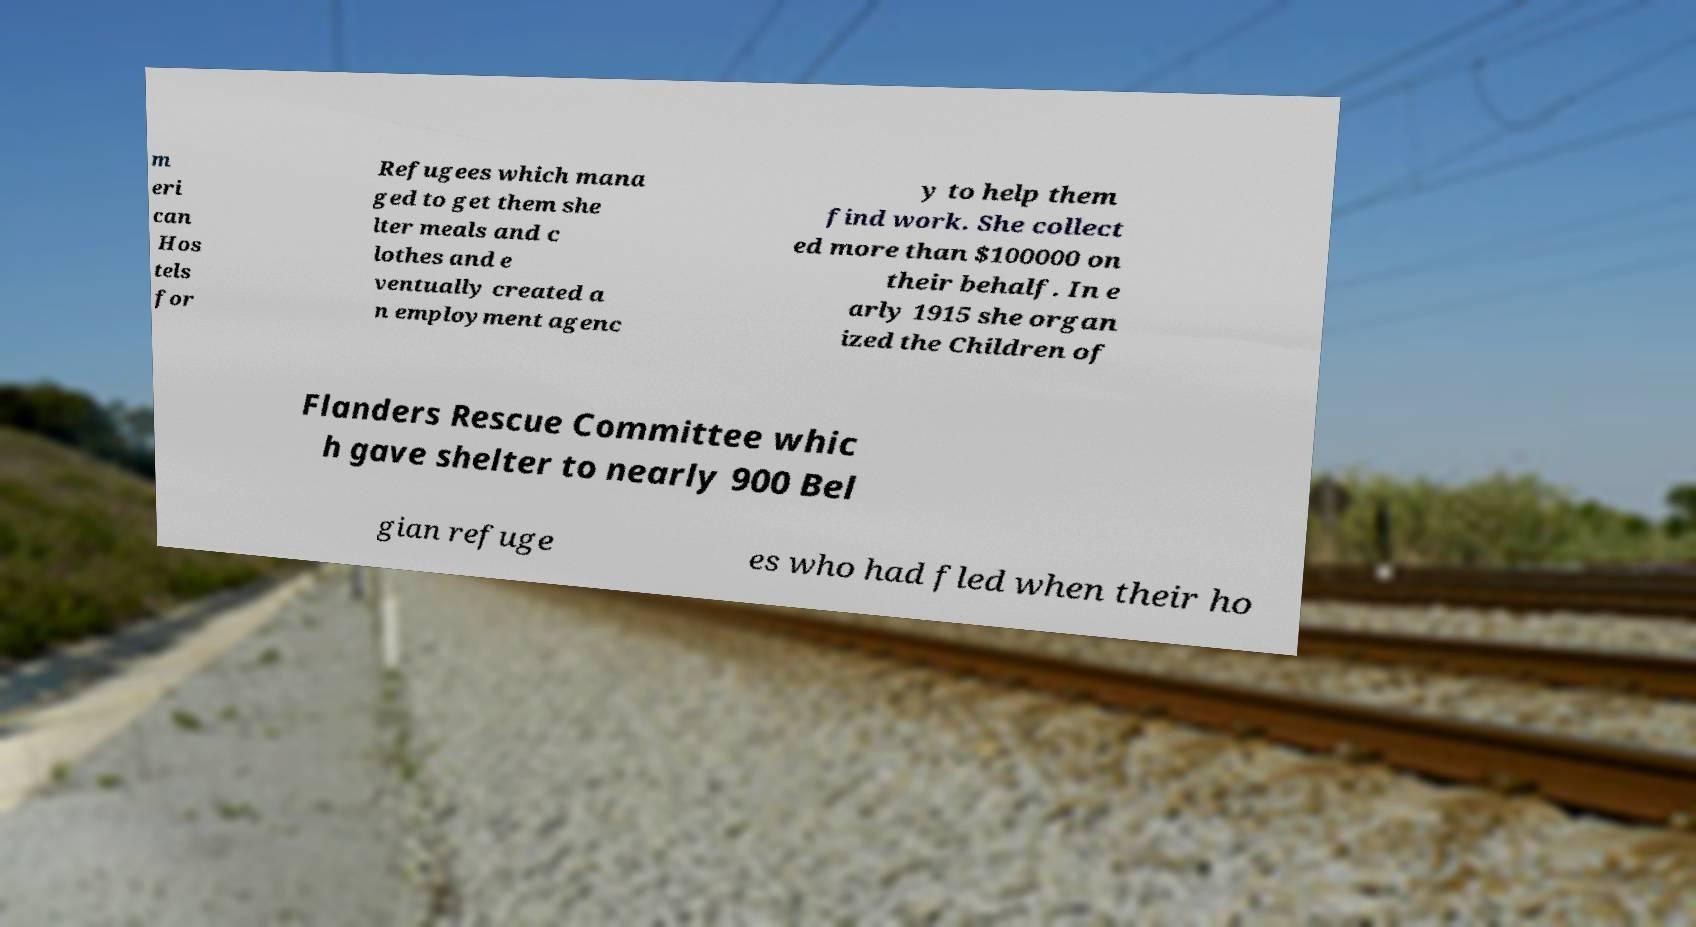Could you assist in decoding the text presented in this image and type it out clearly? m eri can Hos tels for Refugees which mana ged to get them she lter meals and c lothes and e ventually created a n employment agenc y to help them find work. She collect ed more than $100000 on their behalf. In e arly 1915 she organ ized the Children of Flanders Rescue Committee whic h gave shelter to nearly 900 Bel gian refuge es who had fled when their ho 